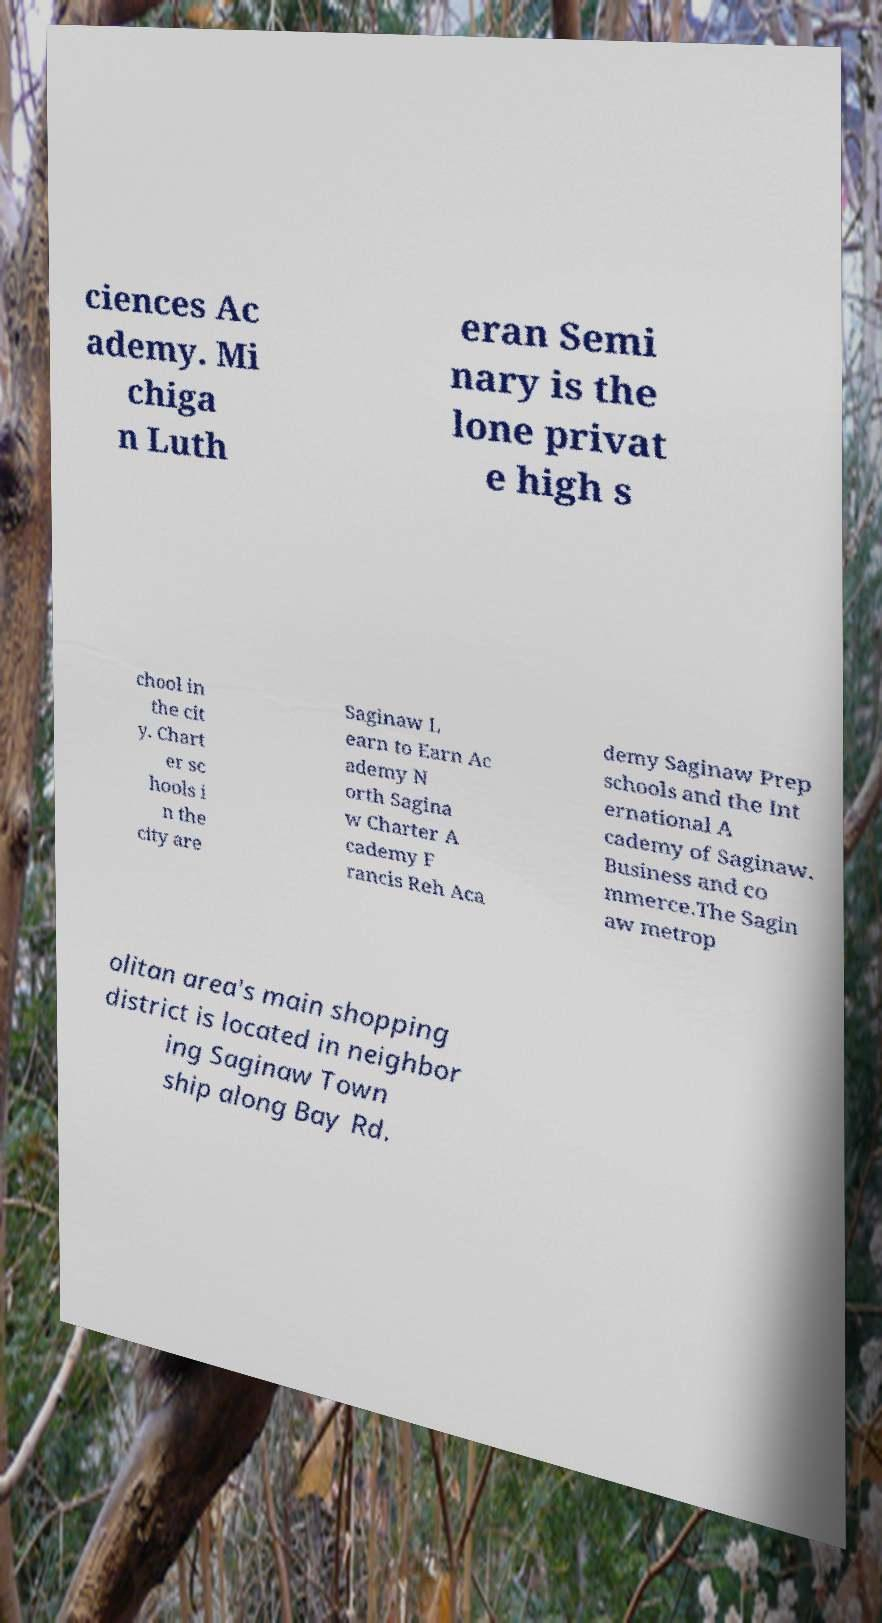Please identify and transcribe the text found in this image. ciences Ac ademy. Mi chiga n Luth eran Semi nary is the lone privat e high s chool in the cit y. Chart er sc hools i n the city are Saginaw L earn to Earn Ac ademy N orth Sagina w Charter A cademy F rancis Reh Aca demy Saginaw Prep schools and the Int ernational A cademy of Saginaw. Business and co mmerce.The Sagin aw metrop olitan area's main shopping district is located in neighbor ing Saginaw Town ship along Bay Rd. 